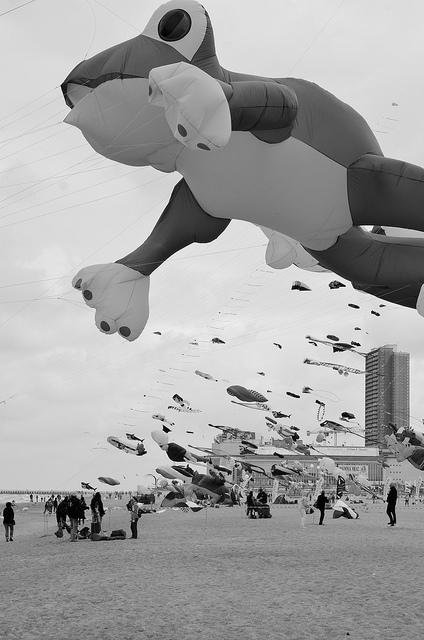Are the people near water?
Be succinct. Yes. Is there a real frog?
Write a very short answer. No. Is the sun out?
Write a very short answer. Yes. 